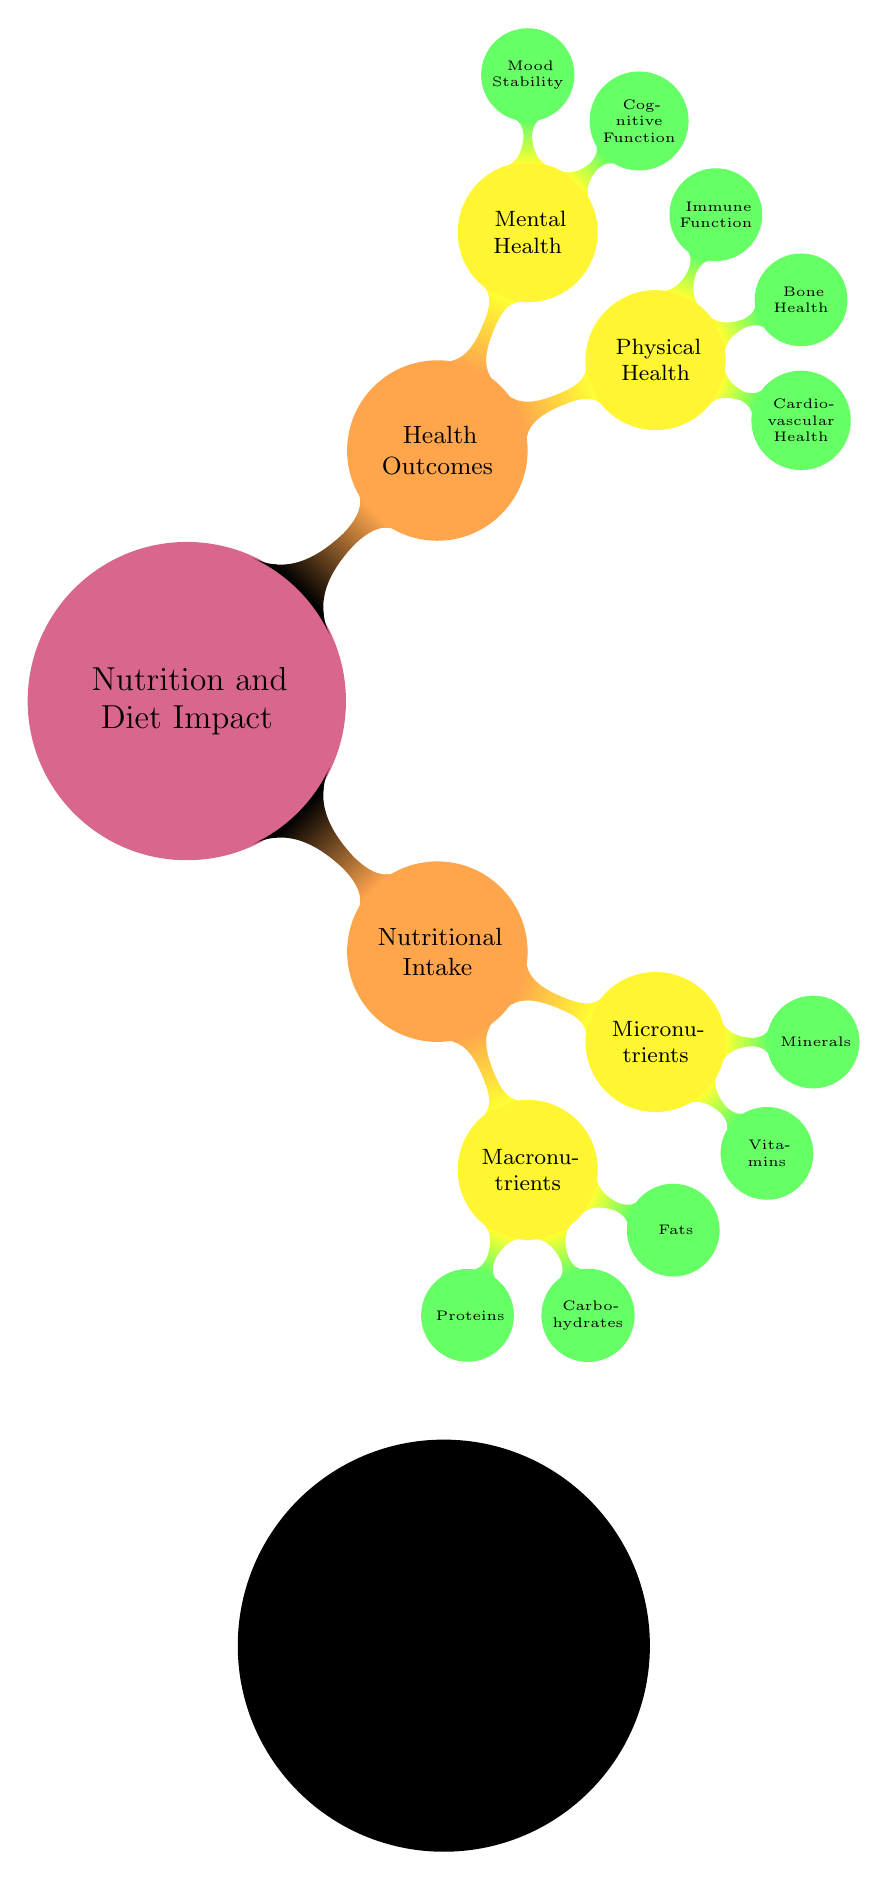What are the two main categories under Nutritional Intake? The diagram shows "Nutritional Intake" as a central node with two child nodes: "Macronutrients" and "Micronutrients". These represent the two main categories.
Answer: Macronutrients, Micronutrients How many types of Macronutrients are listed in the diagram? Under the "Macronutrients" category, there are three specific types listed: "Proteins," "Carbohydrates," and "Fats." Thus, the count is three.
Answer: 3 What health outcome is associated with Mood Stability? "Mood Stability" is a child node under the "Mental Health" category within the "Health Outcomes" section of the diagram. This indicates that it is a health outcome directly linked to mental health.
Answer: Mental Health Which health outcome relates to Cardiovascular Health? "Cardiovascular Health" is a node under "Physical Health," hence it directly relates to that category of health outcomes.
Answer: Physical Health What is the total number of nodes in the Health Outcomes category? The Health Outcomes category has two main nodes: "Physical Health" and "Mental Health." Each of these has sub-nodes (three for Physical Health and two for Mental Health), totaling seven nodes in this category.
Answer: 7 Which type of Micronutrient is related to Minerals? "Minerals" is a sub-node under "Micronutrients," indicating that it falls under this category of nutritional intake. Therefore, the type of Micronutrient related to it is "Minerals."
Answer: Minerals Which category has more sub-nodes: Nutritional Intake or Health Outcomes? "Nutritional Intake" has a total of five sub-nodes (three under Macronutrients and two under Micronutrients), while "Health Outcomes" has five nodes as well (three under Physical Health and two under Mental Health). Since both categories have the same number, there isn't one with more sub-nodes.
Answer: Equal What are the specific components under the Physical Health outcome? The Physical Health outcome consists of three specific components: "Cardiovascular Health," "Bone Health," and "Immune Function," which are all listed under this category in the diagram.
Answer: Cardiovascular Health, Bone Health, Immune Function 